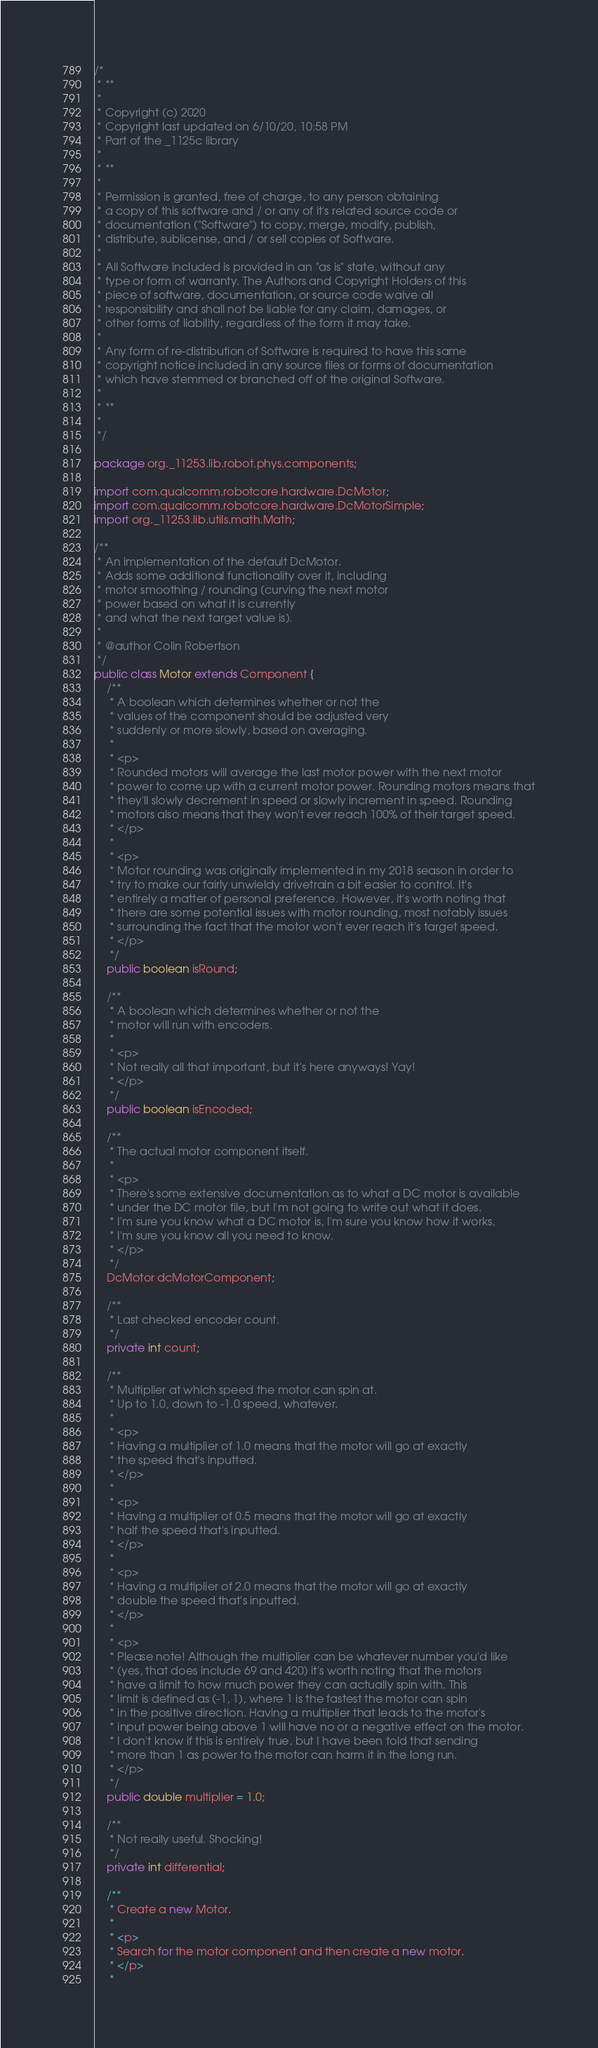Convert code to text. <code><loc_0><loc_0><loc_500><loc_500><_Java_>/*
 * **
 *
 * Copyright (c) 2020
 * Copyright last updated on 6/10/20, 10:58 PM
 * Part of the _1125c library
 *
 * **
 *
 * Permission is granted, free of charge, to any person obtaining
 * a copy of this software and / or any of it's related source code or
 * documentation ("Software") to copy, merge, modify, publish,
 * distribute, sublicense, and / or sell copies of Software.
 *
 * All Software included is provided in an "as is" state, without any
 * type or form of warranty. The Authors and Copyright Holders of this
 * piece of software, documentation, or source code waive all
 * responsibility and shall not be liable for any claim, damages, or
 * other forms of liability, regardless of the form it may take.
 *
 * Any form of re-distribution of Software is required to have this same
 * copyright notice included in any source files or forms of documentation
 * which have stemmed or branched off of the original Software.
 *
 * **
 *
 */

package org._11253.lib.robot.phys.components;

import com.qualcomm.robotcore.hardware.DcMotor;
import com.qualcomm.robotcore.hardware.DcMotorSimple;
import org._11253.lib.utils.math.Math;

/**
 * An implementation of the default DcMotor.
 * Adds some additional functionality over it, including
 * motor smoothing / rounding (curving the next motor
 * power based on what it is currently
 * and what the next target value is).
 *
 * @author Colin Robertson
 */
public class Motor extends Component {
    /**
     * A boolean which determines whether or not the
     * values of the component should be adjusted very
     * suddenly or more slowly, based on averaging.
     *
     * <p>
     * Rounded motors will average the last motor power with the next motor
     * power to come up with a current motor power. Rounding motors means that
     * they'll slowly decrement in speed or slowly increment in speed. Rounding
     * motors also means that they won't ever reach 100% of their target speed.
     * </p>
     *
     * <p>
     * Motor rounding was originally implemented in my 2018 season in order to
     * try to make our fairly unwieldy drivetrain a bit easier to control. It's
     * entirely a matter of personal preference. However, it's worth noting that
     * there are some potential issues with motor rounding, most notably issues
     * surrounding the fact that the motor won't ever reach it's target speed.
     * </p>
     */
    public boolean isRound;

    /**
     * A boolean which determines whether or not the
     * motor will run with encoders.
     *
     * <p>
     * Not really all that important, but it's here anyways! Yay!
     * </p>
     */
    public boolean isEncoded;

    /**
     * The actual motor component itself.
     *
     * <p>
     * There's some extensive documentation as to what a DC motor is available
     * under the DC motor file, but I'm not going to write out what it does.
     * I'm sure you know what a DC motor is, I'm sure you know how it works,
     * I'm sure you know all you need to know.
     * </p>
     */
    DcMotor dcMotorComponent;

    /**
     * Last checked encoder count.
     */
    private int count;

    /**
     * Multiplier at which speed the motor can spin at.
     * Up to 1.0, down to -1.0 speed, whatever.
     *
     * <p>
     * Having a multiplier of 1.0 means that the motor will go at exactly
     * the speed that's inputted.
     * </p>
     *
     * <p>
     * Having a multiplier of 0.5 means that the motor will go at exactly
     * half the speed that's inputted.
     * </p>
     *
     * <p>
     * Having a multiplier of 2.0 means that the motor will go at exactly
     * double the speed that's inputted.
     * </p>
     *
     * <p>
     * Please note! Although the multiplier can be whatever number you'd like
     * (yes, that does include 69 and 420) it's worth noting that the motors
     * have a limit to how much power they can actually spin with. This
     * limit is defined as (-1, 1), where 1 is the fastest the motor can spin
     * in the positive direction. Having a multiplier that leads to the motor's
     * input power being above 1 will have no or a negative effect on the motor.
     * I don't know if this is entirely true, but I have been told that sending
     * more than 1 as power to the motor can harm it in the long run.
     * </p>
     */
    public double multiplier = 1.0;

    /**
     * Not really useful. Shocking!
     */
    private int differential;

    /**
     * Create a new Motor.
     *
     * <p>
     * Search for the motor component and then create a new motor.
     * </p>
     *</code> 